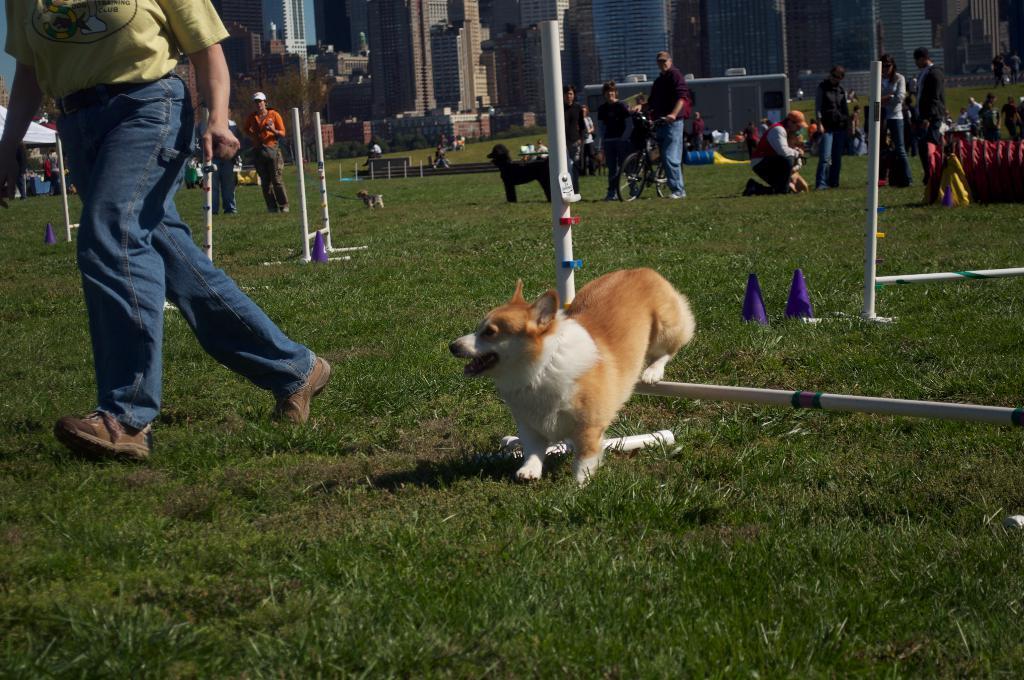Describe this image in one or two sentences. In this picture I can see few buildings and few people standing and a man walking and I can see few dogs and I can see a black color dog and a white and brown color dog and few cones and metal rods and grass on the ground. 